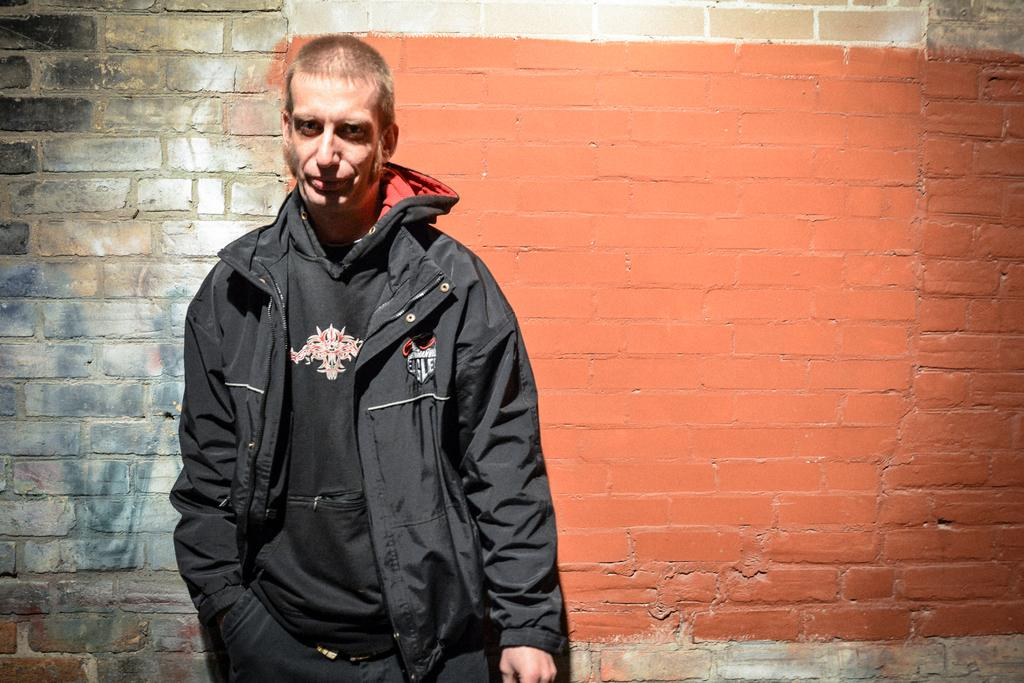What is the main subject of the image? There is a man standing in the image. What is the man wearing in the image? The man is wearing a jacket. What can be seen behind the man in the image? There is a wall behind the man. What type of produce is the man holding in the image? There is no produce visible in the image; the man is only wearing a jacket and standing in front of a wall. 